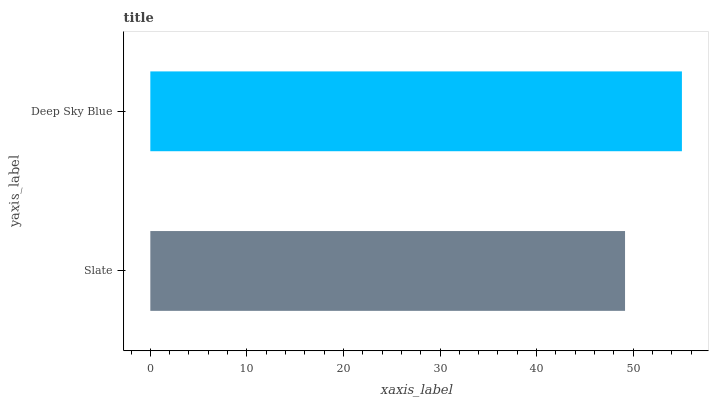Is Slate the minimum?
Answer yes or no. Yes. Is Deep Sky Blue the maximum?
Answer yes or no. Yes. Is Deep Sky Blue the minimum?
Answer yes or no. No. Is Deep Sky Blue greater than Slate?
Answer yes or no. Yes. Is Slate less than Deep Sky Blue?
Answer yes or no. Yes. Is Slate greater than Deep Sky Blue?
Answer yes or no. No. Is Deep Sky Blue less than Slate?
Answer yes or no. No. Is Deep Sky Blue the high median?
Answer yes or no. Yes. Is Slate the low median?
Answer yes or no. Yes. Is Slate the high median?
Answer yes or no. No. Is Deep Sky Blue the low median?
Answer yes or no. No. 